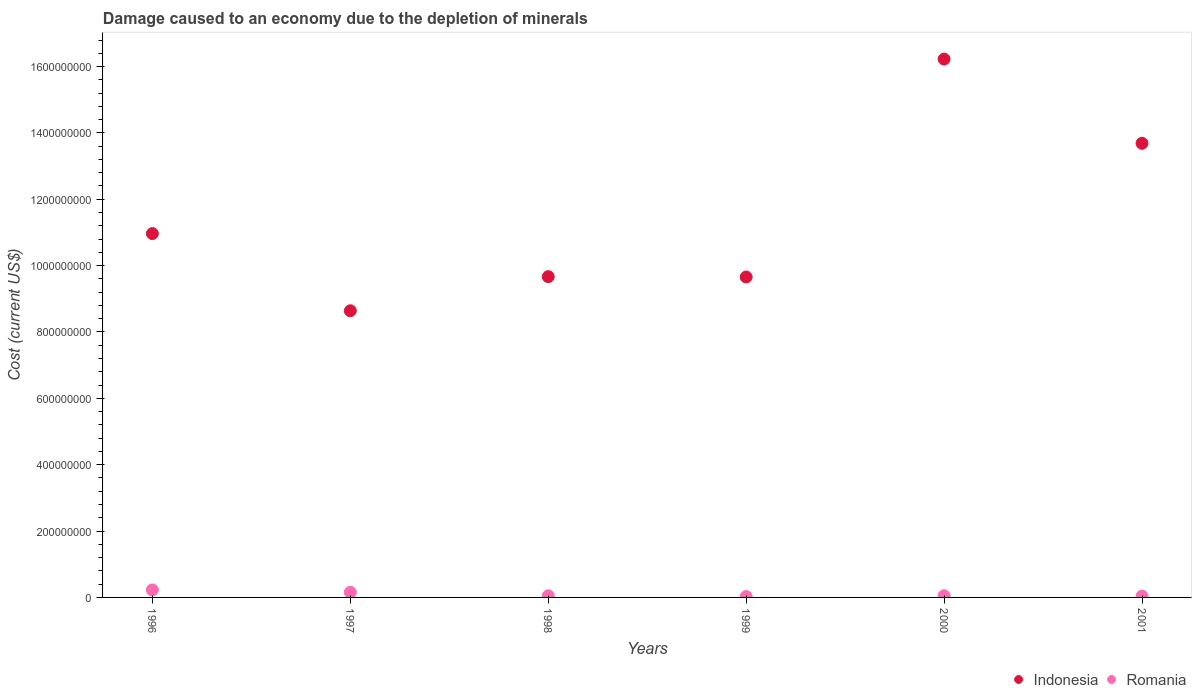How many different coloured dotlines are there?
Ensure brevity in your answer.  2. What is the cost of damage caused due to the depletion of minerals in Indonesia in 2000?
Your answer should be very brief. 1.62e+09. Across all years, what is the maximum cost of damage caused due to the depletion of minerals in Indonesia?
Ensure brevity in your answer.  1.62e+09. Across all years, what is the minimum cost of damage caused due to the depletion of minerals in Indonesia?
Offer a terse response. 8.64e+08. In which year was the cost of damage caused due to the depletion of minerals in Romania maximum?
Your answer should be very brief. 1996. What is the total cost of damage caused due to the depletion of minerals in Romania in the graph?
Offer a very short reply. 5.41e+07. What is the difference between the cost of damage caused due to the depletion of minerals in Romania in 1998 and that in 2001?
Provide a succinct answer. 1.14e+06. What is the difference between the cost of damage caused due to the depletion of minerals in Romania in 1997 and the cost of damage caused due to the depletion of minerals in Indonesia in 1996?
Offer a terse response. -1.08e+09. What is the average cost of damage caused due to the depletion of minerals in Indonesia per year?
Keep it short and to the point. 1.15e+09. In the year 1997, what is the difference between the cost of damage caused due to the depletion of minerals in Indonesia and cost of damage caused due to the depletion of minerals in Romania?
Provide a short and direct response. 8.49e+08. What is the ratio of the cost of damage caused due to the depletion of minerals in Romania in 1997 to that in 2000?
Keep it short and to the point. 3.06. What is the difference between the highest and the second highest cost of damage caused due to the depletion of minerals in Romania?
Offer a terse response. 7.14e+06. What is the difference between the highest and the lowest cost of damage caused due to the depletion of minerals in Indonesia?
Provide a succinct answer. 7.58e+08. Is the sum of the cost of damage caused due to the depletion of minerals in Romania in 1997 and 2000 greater than the maximum cost of damage caused due to the depletion of minerals in Indonesia across all years?
Keep it short and to the point. No. Is the cost of damage caused due to the depletion of minerals in Romania strictly less than the cost of damage caused due to the depletion of minerals in Indonesia over the years?
Ensure brevity in your answer.  Yes. How many years are there in the graph?
Give a very brief answer. 6. Are the values on the major ticks of Y-axis written in scientific E-notation?
Your answer should be compact. No. How many legend labels are there?
Offer a very short reply. 2. How are the legend labels stacked?
Ensure brevity in your answer.  Horizontal. What is the title of the graph?
Make the answer very short. Damage caused to an economy due to the depletion of minerals. What is the label or title of the X-axis?
Ensure brevity in your answer.  Years. What is the label or title of the Y-axis?
Your answer should be compact. Cost (current US$). What is the Cost (current US$) in Indonesia in 1996?
Make the answer very short. 1.10e+09. What is the Cost (current US$) of Romania in 1996?
Your response must be concise. 2.25e+07. What is the Cost (current US$) in Indonesia in 1997?
Keep it short and to the point. 8.64e+08. What is the Cost (current US$) of Romania in 1997?
Give a very brief answer. 1.54e+07. What is the Cost (current US$) in Indonesia in 1998?
Your answer should be very brief. 9.67e+08. What is the Cost (current US$) of Romania in 1998?
Ensure brevity in your answer.  4.90e+06. What is the Cost (current US$) of Indonesia in 1999?
Your response must be concise. 9.66e+08. What is the Cost (current US$) of Romania in 1999?
Provide a short and direct response. 2.51e+06. What is the Cost (current US$) of Indonesia in 2000?
Offer a terse response. 1.62e+09. What is the Cost (current US$) of Romania in 2000?
Offer a terse response. 5.02e+06. What is the Cost (current US$) of Indonesia in 2001?
Offer a terse response. 1.37e+09. What is the Cost (current US$) in Romania in 2001?
Provide a succinct answer. 3.76e+06. Across all years, what is the maximum Cost (current US$) of Indonesia?
Offer a terse response. 1.62e+09. Across all years, what is the maximum Cost (current US$) in Romania?
Your response must be concise. 2.25e+07. Across all years, what is the minimum Cost (current US$) in Indonesia?
Offer a very short reply. 8.64e+08. Across all years, what is the minimum Cost (current US$) of Romania?
Provide a succinct answer. 2.51e+06. What is the total Cost (current US$) of Indonesia in the graph?
Offer a terse response. 6.88e+09. What is the total Cost (current US$) in Romania in the graph?
Provide a succinct answer. 5.41e+07. What is the difference between the Cost (current US$) of Indonesia in 1996 and that in 1997?
Provide a succinct answer. 2.33e+08. What is the difference between the Cost (current US$) of Romania in 1996 and that in 1997?
Provide a succinct answer. 7.14e+06. What is the difference between the Cost (current US$) of Indonesia in 1996 and that in 1998?
Make the answer very short. 1.30e+08. What is the difference between the Cost (current US$) in Romania in 1996 and that in 1998?
Provide a succinct answer. 1.76e+07. What is the difference between the Cost (current US$) of Indonesia in 1996 and that in 1999?
Your response must be concise. 1.31e+08. What is the difference between the Cost (current US$) in Romania in 1996 and that in 1999?
Provide a succinct answer. 2.00e+07. What is the difference between the Cost (current US$) of Indonesia in 1996 and that in 2000?
Your answer should be compact. -5.26e+08. What is the difference between the Cost (current US$) in Romania in 1996 and that in 2000?
Offer a terse response. 1.75e+07. What is the difference between the Cost (current US$) in Indonesia in 1996 and that in 2001?
Offer a very short reply. -2.72e+08. What is the difference between the Cost (current US$) of Romania in 1996 and that in 2001?
Provide a short and direct response. 1.87e+07. What is the difference between the Cost (current US$) in Indonesia in 1997 and that in 1998?
Offer a very short reply. -1.03e+08. What is the difference between the Cost (current US$) in Romania in 1997 and that in 1998?
Offer a terse response. 1.05e+07. What is the difference between the Cost (current US$) in Indonesia in 1997 and that in 1999?
Your response must be concise. -1.02e+08. What is the difference between the Cost (current US$) of Romania in 1997 and that in 1999?
Offer a very short reply. 1.29e+07. What is the difference between the Cost (current US$) in Indonesia in 1997 and that in 2000?
Provide a succinct answer. -7.58e+08. What is the difference between the Cost (current US$) in Romania in 1997 and that in 2000?
Provide a succinct answer. 1.03e+07. What is the difference between the Cost (current US$) of Indonesia in 1997 and that in 2001?
Your response must be concise. -5.05e+08. What is the difference between the Cost (current US$) in Romania in 1997 and that in 2001?
Your response must be concise. 1.16e+07. What is the difference between the Cost (current US$) of Indonesia in 1998 and that in 1999?
Offer a terse response. 1.07e+06. What is the difference between the Cost (current US$) in Romania in 1998 and that in 1999?
Your answer should be compact. 2.39e+06. What is the difference between the Cost (current US$) of Indonesia in 1998 and that in 2000?
Give a very brief answer. -6.56e+08. What is the difference between the Cost (current US$) of Romania in 1998 and that in 2000?
Your answer should be compact. -1.20e+05. What is the difference between the Cost (current US$) in Indonesia in 1998 and that in 2001?
Your answer should be compact. -4.02e+08. What is the difference between the Cost (current US$) of Romania in 1998 and that in 2001?
Your answer should be very brief. 1.14e+06. What is the difference between the Cost (current US$) in Indonesia in 1999 and that in 2000?
Provide a succinct answer. -6.57e+08. What is the difference between the Cost (current US$) of Romania in 1999 and that in 2000?
Give a very brief answer. -2.51e+06. What is the difference between the Cost (current US$) of Indonesia in 1999 and that in 2001?
Provide a succinct answer. -4.03e+08. What is the difference between the Cost (current US$) of Romania in 1999 and that in 2001?
Your answer should be very brief. -1.25e+06. What is the difference between the Cost (current US$) of Indonesia in 2000 and that in 2001?
Offer a terse response. 2.54e+08. What is the difference between the Cost (current US$) in Romania in 2000 and that in 2001?
Your response must be concise. 1.26e+06. What is the difference between the Cost (current US$) of Indonesia in 1996 and the Cost (current US$) of Romania in 1997?
Provide a short and direct response. 1.08e+09. What is the difference between the Cost (current US$) of Indonesia in 1996 and the Cost (current US$) of Romania in 1998?
Offer a very short reply. 1.09e+09. What is the difference between the Cost (current US$) of Indonesia in 1996 and the Cost (current US$) of Romania in 1999?
Offer a terse response. 1.09e+09. What is the difference between the Cost (current US$) in Indonesia in 1996 and the Cost (current US$) in Romania in 2000?
Your answer should be compact. 1.09e+09. What is the difference between the Cost (current US$) of Indonesia in 1996 and the Cost (current US$) of Romania in 2001?
Offer a terse response. 1.09e+09. What is the difference between the Cost (current US$) of Indonesia in 1997 and the Cost (current US$) of Romania in 1998?
Provide a succinct answer. 8.59e+08. What is the difference between the Cost (current US$) in Indonesia in 1997 and the Cost (current US$) in Romania in 1999?
Provide a succinct answer. 8.61e+08. What is the difference between the Cost (current US$) in Indonesia in 1997 and the Cost (current US$) in Romania in 2000?
Keep it short and to the point. 8.59e+08. What is the difference between the Cost (current US$) of Indonesia in 1997 and the Cost (current US$) of Romania in 2001?
Your answer should be compact. 8.60e+08. What is the difference between the Cost (current US$) in Indonesia in 1998 and the Cost (current US$) in Romania in 1999?
Offer a very short reply. 9.64e+08. What is the difference between the Cost (current US$) in Indonesia in 1998 and the Cost (current US$) in Romania in 2000?
Provide a succinct answer. 9.62e+08. What is the difference between the Cost (current US$) in Indonesia in 1998 and the Cost (current US$) in Romania in 2001?
Keep it short and to the point. 9.63e+08. What is the difference between the Cost (current US$) of Indonesia in 1999 and the Cost (current US$) of Romania in 2000?
Provide a short and direct response. 9.61e+08. What is the difference between the Cost (current US$) of Indonesia in 1999 and the Cost (current US$) of Romania in 2001?
Offer a terse response. 9.62e+08. What is the difference between the Cost (current US$) of Indonesia in 2000 and the Cost (current US$) of Romania in 2001?
Your response must be concise. 1.62e+09. What is the average Cost (current US$) of Indonesia per year?
Your answer should be compact. 1.15e+09. What is the average Cost (current US$) of Romania per year?
Make the answer very short. 9.01e+06. In the year 1996, what is the difference between the Cost (current US$) in Indonesia and Cost (current US$) in Romania?
Offer a very short reply. 1.07e+09. In the year 1997, what is the difference between the Cost (current US$) of Indonesia and Cost (current US$) of Romania?
Your response must be concise. 8.49e+08. In the year 1998, what is the difference between the Cost (current US$) of Indonesia and Cost (current US$) of Romania?
Your answer should be very brief. 9.62e+08. In the year 1999, what is the difference between the Cost (current US$) of Indonesia and Cost (current US$) of Romania?
Make the answer very short. 9.63e+08. In the year 2000, what is the difference between the Cost (current US$) in Indonesia and Cost (current US$) in Romania?
Provide a short and direct response. 1.62e+09. In the year 2001, what is the difference between the Cost (current US$) in Indonesia and Cost (current US$) in Romania?
Your answer should be very brief. 1.36e+09. What is the ratio of the Cost (current US$) of Indonesia in 1996 to that in 1997?
Provide a short and direct response. 1.27. What is the ratio of the Cost (current US$) in Romania in 1996 to that in 1997?
Offer a terse response. 1.46. What is the ratio of the Cost (current US$) of Indonesia in 1996 to that in 1998?
Give a very brief answer. 1.13. What is the ratio of the Cost (current US$) of Romania in 1996 to that in 1998?
Your answer should be very brief. 4.59. What is the ratio of the Cost (current US$) of Indonesia in 1996 to that in 1999?
Offer a very short reply. 1.14. What is the ratio of the Cost (current US$) in Romania in 1996 to that in 1999?
Your answer should be very brief. 8.96. What is the ratio of the Cost (current US$) of Indonesia in 1996 to that in 2000?
Offer a terse response. 0.68. What is the ratio of the Cost (current US$) in Romania in 1996 to that in 2000?
Keep it short and to the point. 4.48. What is the ratio of the Cost (current US$) of Indonesia in 1996 to that in 2001?
Offer a very short reply. 0.8. What is the ratio of the Cost (current US$) of Romania in 1996 to that in 2001?
Keep it short and to the point. 5.98. What is the ratio of the Cost (current US$) in Indonesia in 1997 to that in 1998?
Your answer should be very brief. 0.89. What is the ratio of the Cost (current US$) of Romania in 1997 to that in 1998?
Provide a succinct answer. 3.14. What is the ratio of the Cost (current US$) in Indonesia in 1997 to that in 1999?
Provide a short and direct response. 0.89. What is the ratio of the Cost (current US$) of Romania in 1997 to that in 1999?
Make the answer very short. 6.11. What is the ratio of the Cost (current US$) in Indonesia in 1997 to that in 2000?
Offer a terse response. 0.53. What is the ratio of the Cost (current US$) in Romania in 1997 to that in 2000?
Offer a terse response. 3.06. What is the ratio of the Cost (current US$) in Indonesia in 1997 to that in 2001?
Your answer should be very brief. 0.63. What is the ratio of the Cost (current US$) in Romania in 1997 to that in 2001?
Give a very brief answer. 4.09. What is the ratio of the Cost (current US$) in Indonesia in 1998 to that in 1999?
Offer a very short reply. 1. What is the ratio of the Cost (current US$) of Romania in 1998 to that in 1999?
Ensure brevity in your answer.  1.95. What is the ratio of the Cost (current US$) of Indonesia in 1998 to that in 2000?
Make the answer very short. 0.6. What is the ratio of the Cost (current US$) of Romania in 1998 to that in 2000?
Provide a succinct answer. 0.98. What is the ratio of the Cost (current US$) of Indonesia in 1998 to that in 2001?
Give a very brief answer. 0.71. What is the ratio of the Cost (current US$) of Romania in 1998 to that in 2001?
Ensure brevity in your answer.  1.3. What is the ratio of the Cost (current US$) in Indonesia in 1999 to that in 2000?
Provide a short and direct response. 0.6. What is the ratio of the Cost (current US$) in Romania in 1999 to that in 2000?
Your answer should be compact. 0.5. What is the ratio of the Cost (current US$) in Indonesia in 1999 to that in 2001?
Provide a succinct answer. 0.71. What is the ratio of the Cost (current US$) in Romania in 1999 to that in 2001?
Provide a short and direct response. 0.67. What is the ratio of the Cost (current US$) of Indonesia in 2000 to that in 2001?
Offer a terse response. 1.19. What is the ratio of the Cost (current US$) in Romania in 2000 to that in 2001?
Offer a terse response. 1.33. What is the difference between the highest and the second highest Cost (current US$) of Indonesia?
Keep it short and to the point. 2.54e+08. What is the difference between the highest and the second highest Cost (current US$) of Romania?
Ensure brevity in your answer.  7.14e+06. What is the difference between the highest and the lowest Cost (current US$) in Indonesia?
Your answer should be very brief. 7.58e+08. What is the difference between the highest and the lowest Cost (current US$) of Romania?
Keep it short and to the point. 2.00e+07. 